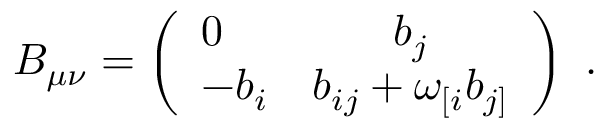Convert formula to latex. <formula><loc_0><loc_0><loc_500><loc_500>B _ { \mu \nu } = \left ( \begin{array} { l c } { 0 } & { { b _ { j } } } \\ { { - b _ { i } } } & { { b _ { i j } + \omega _ { [ i } b _ { j ] } } } \end{array} \right ) \ .</formula> 